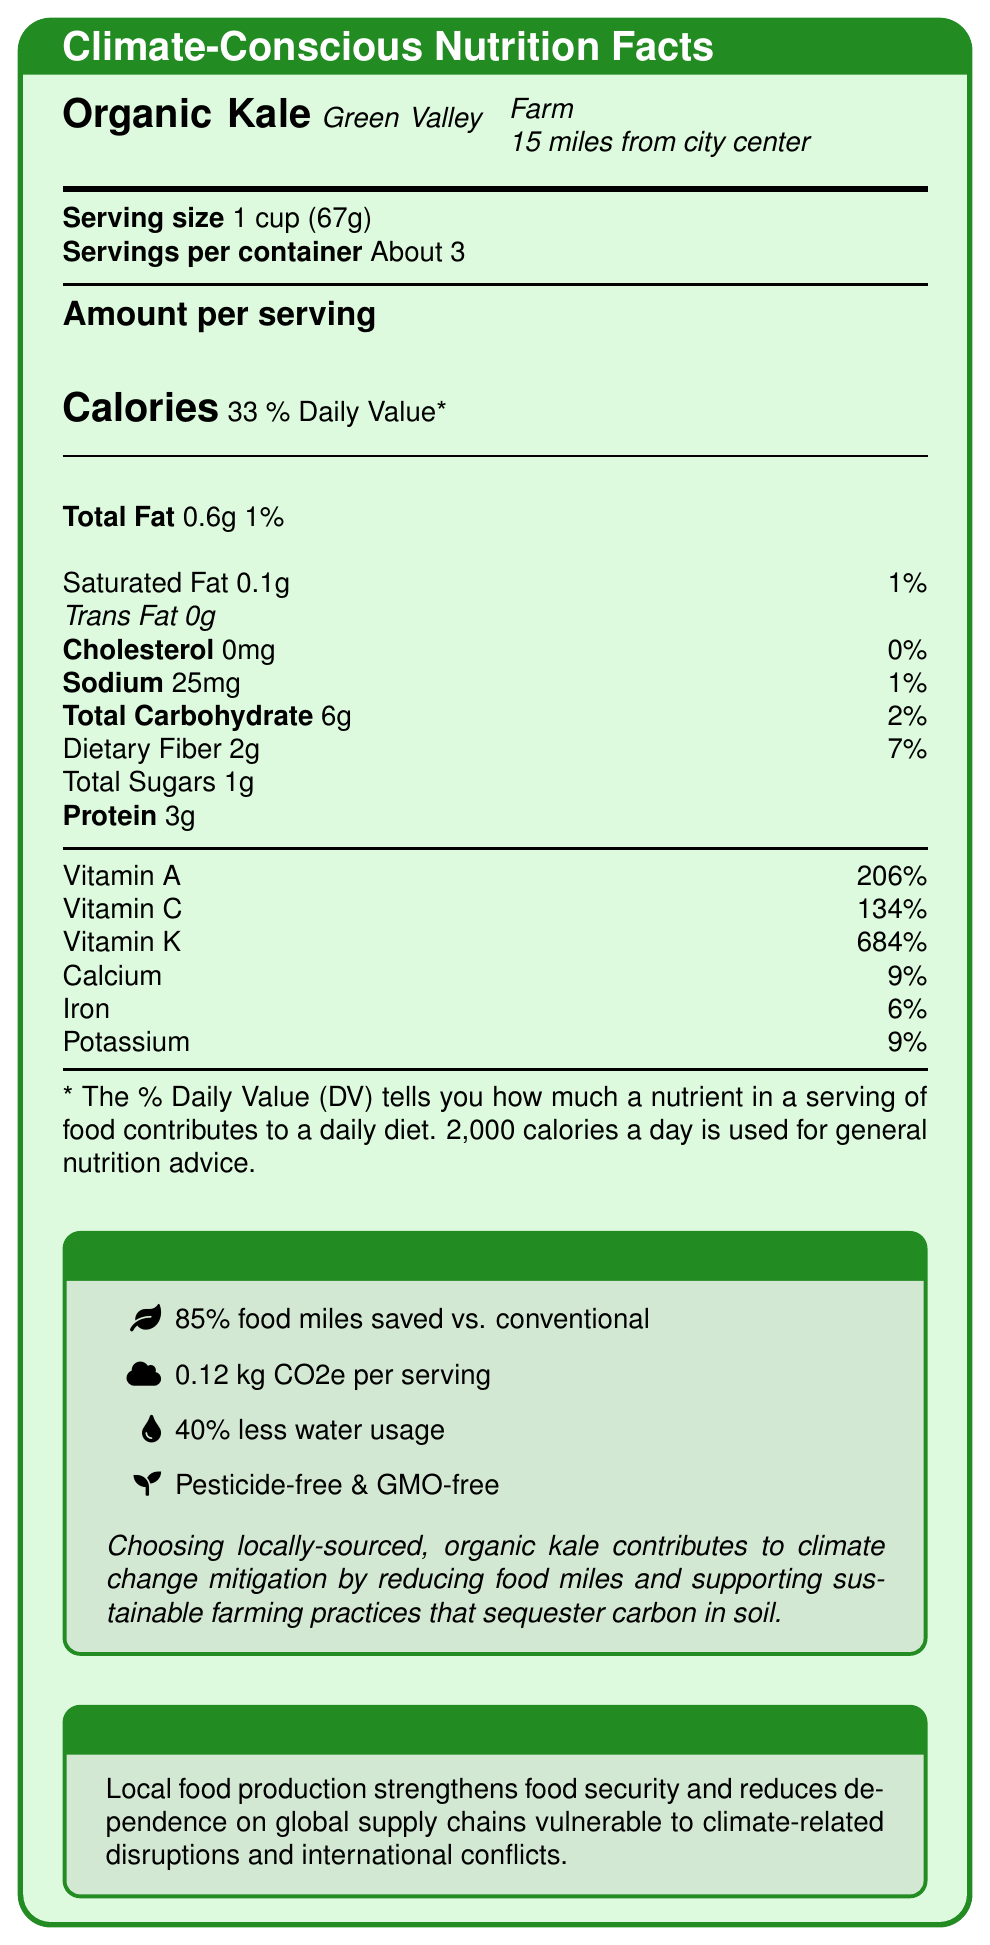what is the serving size? The serving size indicated on the Nutrition Facts Label is 1 cup, which weighs 67 grams.
Answer: 1 cup (67g) how many calories are in one serving? The amount per serving section of the label states that there are 33 calories in one serving.
Answer: 33 calories which vitamin has the highest percentage of daily value (DV) in this product? The percentage daily value for Vitamin K is 684%, which is higher than the values for other vitamins listed.
Answer: Vitamin K how much protein is in one serving? The Nutrition Facts Label shows that there are 3 grams of protein in one serving.
Answer: 3g where is the kale sourced from? The source information on the label mentions Green Valley Farm, located 15 miles from the city center.
Answer: Green Valley Farm, 15 miles from city center what are the total carbohydrate and dietary fiber contents per serving? The label mentions 6 grams of total carbohydrates and 2 grams of dietary fiber per serving.
Answer: 6g of total carbohydrates, 2g of dietary fiber what is the carbon footprint per serving? The "Climate Impact" section of the label states the carbon footprint as 0.12 kg CO2e per serving.
Answer: 0.12 kg CO2e Is the kale pesticide-free and GMO-free? The "Climate Impact" section lists the kale as being pesticide-free and GMO-free.
Answer: Yes what are the food miles saved compared to conventionally sourced kale? The label's "Climate Impact" section mentions that food miles saved are 85% compared to conventionally sourced kale.
Answer: 85% what is the percentage of Vitamin A daily value per serving? A. 134% B. 206% C. 684% The label indicates that the Vitamin A daily value per serving is 206%.
Answer: B. 206% how much sodium is in one serving? A. 0mg B. 25mg C. 50mg D. 75mg The label lists the sodium content per serving as 25mg.
Answer: B. 25mg is the kale contributing to reducing transportation emissions? The "Sustainability Facts" section lists "Reduces transportation emissions" as one of the benefits.
Answer: Yes summarize the main idea of the document. The label provides detailed nutritional information, underscores the climate impact of choosing locally-sourced, organic kale, and describes its role in supporting local economies and reducing dependency on global supply chains.
Answer: The document presents the Nutrition Facts Label for Organic Kale sourced from Green Valley Farm, highlighting its low calories, high vitamin content, minimal food miles, and significant environmental benefits. It also explains the geopolitical importance of local food production for food security. how much water is used compared to conventional farming? The "Climate Impact" section states that the Organic Kale uses 40% less water than conventional farming.
Answer: 40% less what is the potassium daily value percentage per serving? The Nutrition Facts section lists potassium as having a daily value percentage of 9%.
Answer: 9% how many grams of trans fat are in one serving? The label specifies that there are 0 grams of trans fat per serving.
Answer: 0g what are some sustainability benefits mentioned? The sustainability facts section of the label mentions these benefits.
Answer: Supports local economy, Reduces transportation emissions, Enhances soil health through organic practices, Promotes biodiversity in the region what is the kale's contribution to climate change mitigation? The "Climate Impact" section explains that locally-sourced, organic kale contributes to climate change mitigation by reducing food miles and supporting sustainable farming practices that sequester carbon in soil.
Answer: Reduces food miles, Supports sustainable farming practices that sequester carbon in soil which farm produces the organic kale? A. Sunshine Farm B. Green Valley Farm C. Lakeview Farm The label indicates that the kale is produced by Green Valley Farm.
Answer: B. Green Valley Farm how many servings are there per container? The serving information states that there are about 3 servings per container.
Answer: About 3 what is the potential impact on global supply chains? The "Geopolitical Context" section addresses this impact.
Answer: Strengthens food security and reduces dependence on global supply chains vulnerable to climate-related disruptions and international conflicts what are the exact sustainability practices used by the farm? The document lists some general sustainability benefits but does not provide detailed practices specifically used by the farm.
Answer: Not enough information what is the total amount of sugars per serving? The label indicates that there is a total of 1 gram of sugars per serving.
Answer: 1g 